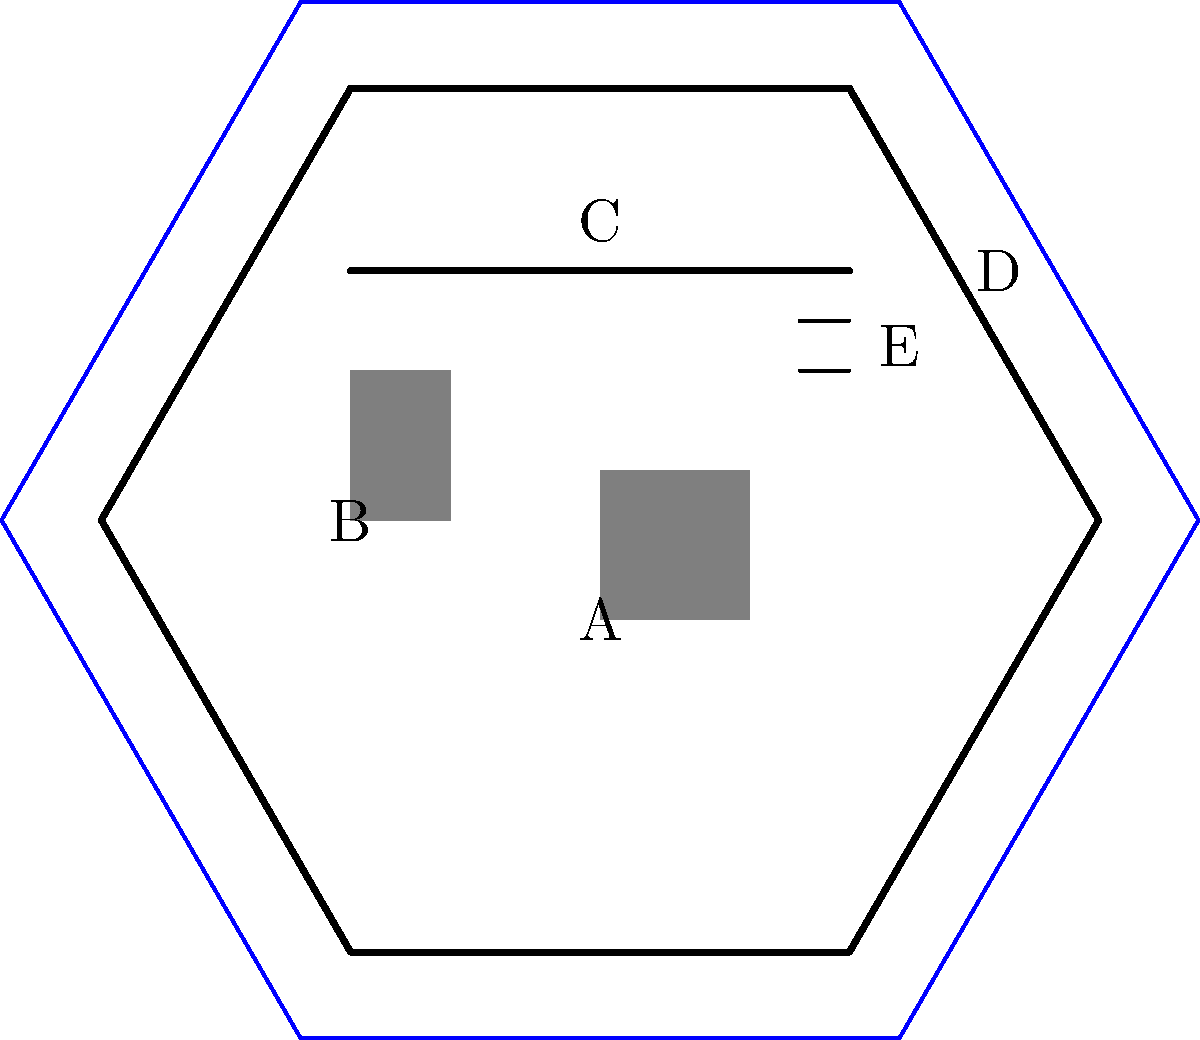In this simplified diagram of a medieval castle, identify the fortification elements labeled A through E. Which of these elements would typically be the strongest and most heavily defended part of the castle? To answer this question, let's first identify each element in the diagram:

1. A: This central, square structure represents the keep or donjon. It was the heart of the castle and served as the last line of defense.

2. B: The rectangular structure at the entrance is the gatehouse, which controlled access to the castle.

3. C: The line connecting different parts of the castle represents the curtain wall, the outer defensive wall.

4. D: The blue line surrounding the castle depicts the moat, a wide ditch often filled with water.

5. E: The small lines in the wall represent arrow loops, narrow vertical openings that allowed defenders to shoot arrows while remaining protected.

Among these elements, the keep (A) would typically be the strongest and most heavily defended part of the castle for several reasons:

1. Central location: The keep was usually situated at the heart of the castle, making it the last line of defense if outer fortifications were breached.

2. Thick walls: Keeps had the thickest walls in the castle, sometimes up to 3-4 meters thick, making them extremely difficult to penetrate.

3. Height advantage: Keeps were often the tallest structures in the castle, providing a superior vantage point for defense and observation.

4. Self-sufficiency: Keeps were designed to be self-sufficient, containing supplies, living quarters, and sometimes even their own water sources, allowing for prolonged resistance even if the rest of the castle fell.

5. Symbol of power: As the residence of the lord or noble, the keep was a symbol of power and authority, and thus received the most attention in terms of defense and construction.

While other elements like the gatehouse (B) and curtain walls (C) were crucial for overall castle defense, the keep remained the ultimate stronghold within the castle complex.
Answer: The keep (A) 